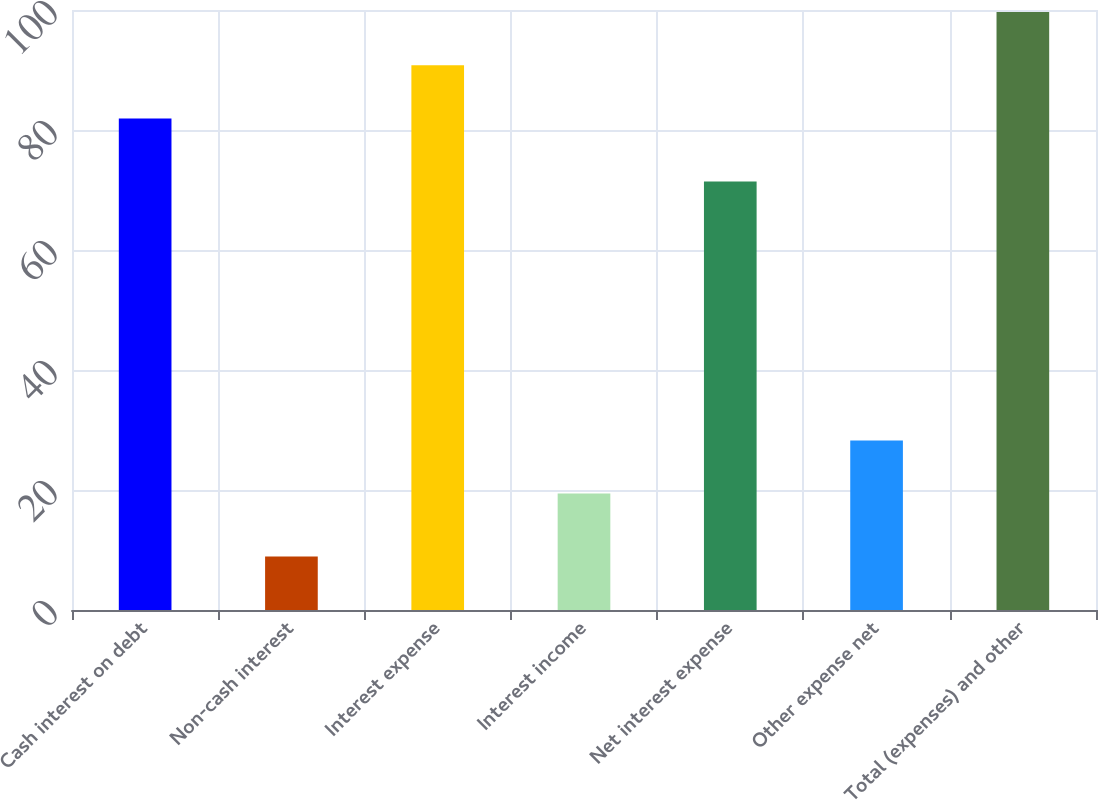Convert chart to OTSL. <chart><loc_0><loc_0><loc_500><loc_500><bar_chart><fcel>Cash interest on debt<fcel>Non-cash interest<fcel>Interest expense<fcel>Interest income<fcel>Net interest expense<fcel>Other expense net<fcel>Total (expenses) and other<nl><fcel>81.9<fcel>8.9<fcel>90.8<fcel>19.4<fcel>71.4<fcel>28.27<fcel>99.67<nl></chart> 